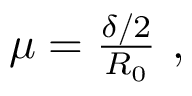Convert formula to latex. <formula><loc_0><loc_0><loc_500><loc_500>\begin{array} { r } { \mu = \frac { \delta / 2 } { R _ { 0 } } , } \end{array}</formula> 